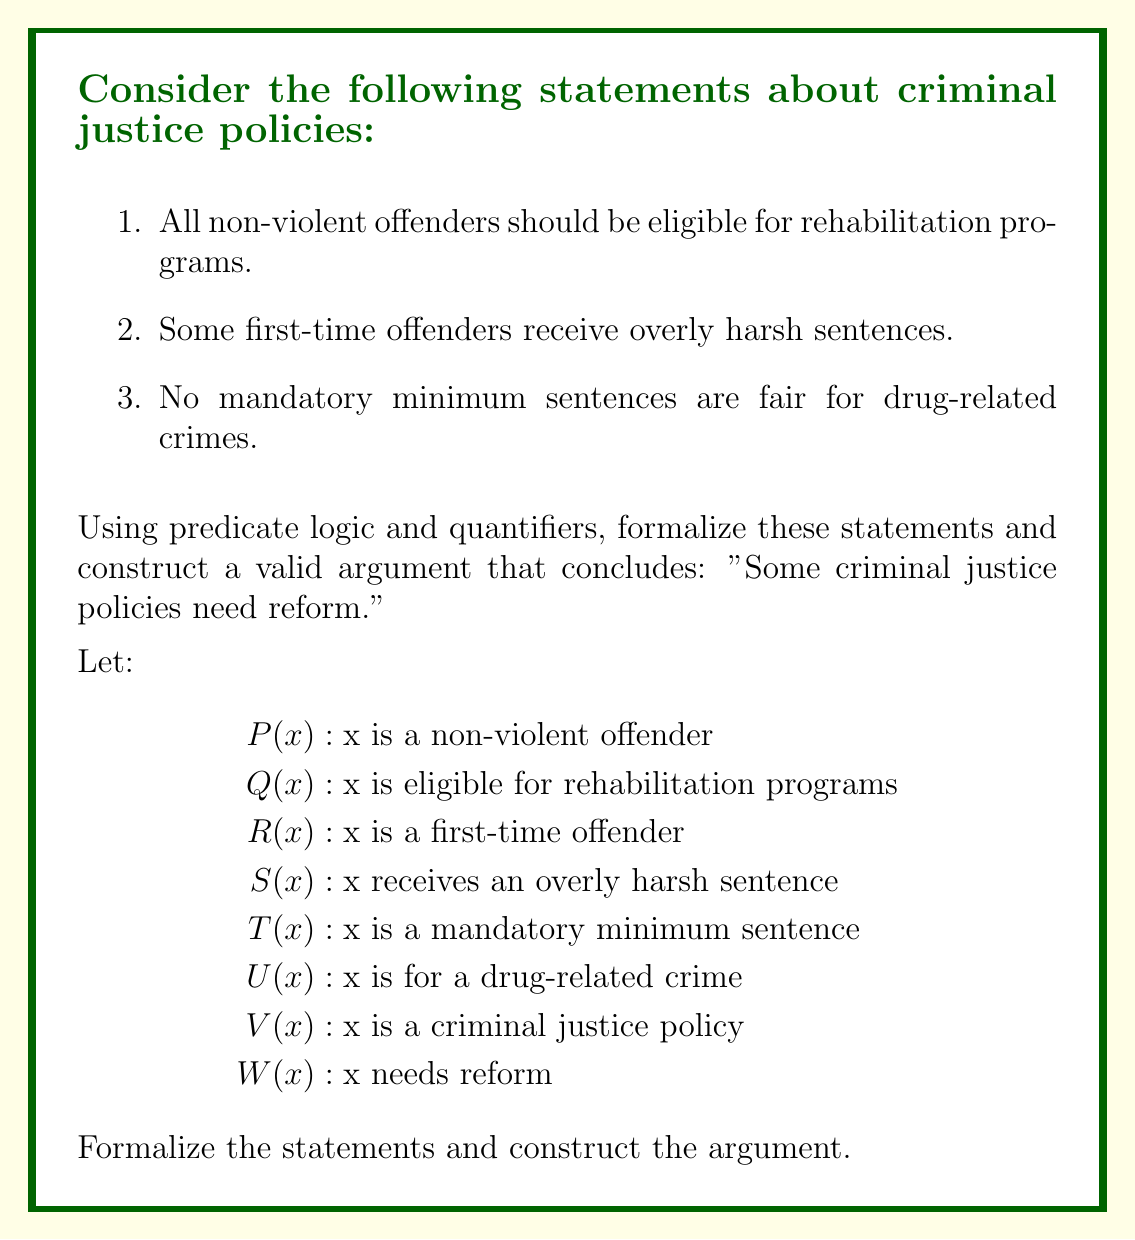Help me with this question. Let's formalize each statement and construct the argument step-by-step:

1. All non-violent offenders should be eligible for rehabilitation programs:
   $$\forall x(P(x) \rightarrow Q(x))$$

2. Some first-time offenders receive overly harsh sentences:
   $$\exists x(R(x) \land S(x))$$

3. No mandatory minimum sentences are fair for drug-related crimes:
   $$\forall x((T(x) \land U(x)) \rightarrow \neg W(x))$$

Now, let's construct the argument:

4. Premise: All policies that deny rehabilitation to non-violent offenders need reform:
   $$\forall x((V(x) \land \exists y(P(y) \land \neg Q(y))) \rightarrow W(x))$$

5. Premise: All policies that allow overly harsh sentences for first-time offenders need reform:
   $$\forall x((V(x) \land \exists y(R(y) \land S(y))) \rightarrow W(x))$$

6. Premise: All policies that include unfair mandatory minimum sentences for drug-related crimes need reform:
   $$\forall x((V(x) \land \exists y(T(y) \land U(y) \land \neg W(y))) \rightarrow W(x))$$

7. From statements 2 and 5, we can conclude:
   $$\exists x(V(x) \land W(x))$$

This conclusion states that "Some criminal justice policies need reform," which is what we aimed to prove.
Answer: $$\exists x(V(x) \land W(x))$$

This logical statement represents the conclusion: "Some criminal justice policies need reform." 